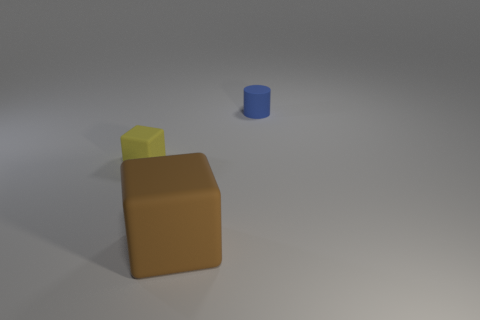Add 2 big brown matte objects. How many objects exist? 5 Add 1 big green cubes. How many big green cubes exist? 1 Subtract 0 gray blocks. How many objects are left? 3 Subtract all cylinders. How many objects are left? 2 Subtract 2 blocks. How many blocks are left? 0 Subtract all gray blocks. Subtract all cyan cylinders. How many blocks are left? 2 Subtract all gray balls. How many yellow cubes are left? 1 Subtract all brown rubber blocks. Subtract all yellow things. How many objects are left? 1 Add 1 big brown matte objects. How many big brown matte objects are left? 2 